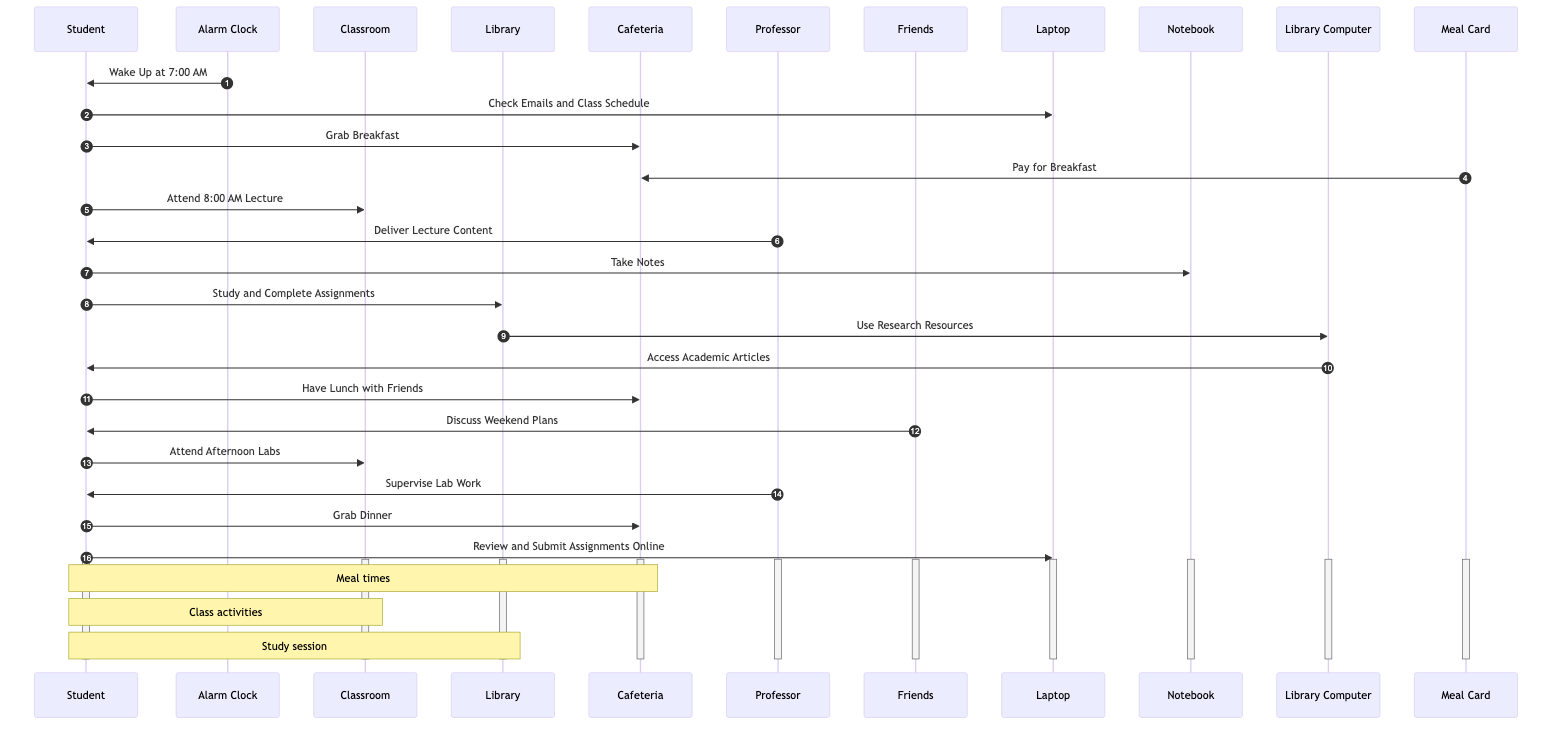What time does the Alarm Clock wake the Student? According to the diagram, the Alarm Clock sends a message to the Student stating to wake up at 7:00 AM. This is the first interaction in the sequence.
Answer: 7:00 AM How many actors are involved in this sequence diagram? The sequence diagram lists eight actors, which include Student, Alarm Clock, Classroom, Library, Cafeteria, Professor, Friends, and Meal Card.
Answer: 8 Which activity follows the Student checking emails? After the Student checks emails on the Laptop, the next activity is grabbing breakfast from the Cafeteria. This follows directly in the sequence of messages.
Answer: Grab Breakfast What does the Student do after attending the 8:00 AM lecture? After attending the 8:00 AM lecture, the Student studies and completes assignments in the Library, as indicated by the sequence of messages following the lecture.
Answer: Study and Complete Assignments How many meals does the Student grab throughout the day? The Student grabs three meals during the day: breakfast, lunch, and dinner as shown in the series of interactions with the Cafeteria.
Answer: 3 Which tool does the Student use while studying in the Library? While studying in the Library, the Student uses the Library Computer to access research resources and academic articles, as indicated in the flow of messages.
Answer: Library Computer What is the relationship between the Student and the Professor during lab work? The relationship between the Student and the Professor during lab work is that the Professor supervises the Student’s lab work, as shown in the sequence diagram.
Answer: Supervise Lab Work What do the Friends discuss with the Student during lunch? During lunch, the Friends discuss weekend plans with the Student, as indicated in the sequence of messages during the lunch interactions.
Answer: Discuss Weekend Plans 